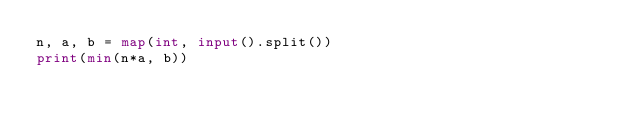<code> <loc_0><loc_0><loc_500><loc_500><_Python_>n, a, b = map(int, input().split())
print(min(n*a, b))</code> 